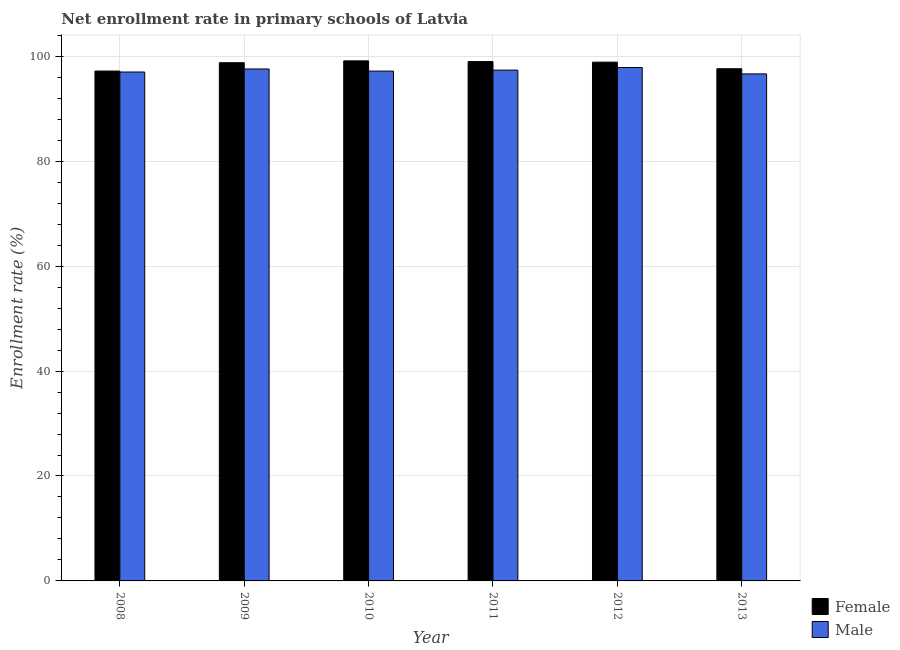How many groups of bars are there?
Ensure brevity in your answer.  6. Are the number of bars on each tick of the X-axis equal?
Ensure brevity in your answer.  Yes. How many bars are there on the 1st tick from the left?
Offer a terse response. 2. How many bars are there on the 6th tick from the right?
Offer a terse response. 2. What is the enrollment rate of male students in 2013?
Offer a very short reply. 96.65. Across all years, what is the maximum enrollment rate of male students?
Provide a succinct answer. 97.86. Across all years, what is the minimum enrollment rate of male students?
Give a very brief answer. 96.65. In which year was the enrollment rate of female students maximum?
Your response must be concise. 2010. What is the total enrollment rate of female students in the graph?
Ensure brevity in your answer.  590.6. What is the difference between the enrollment rate of male students in 2008 and that in 2009?
Your answer should be very brief. -0.58. What is the difference between the enrollment rate of male students in 2010 and the enrollment rate of female students in 2013?
Give a very brief answer. 0.53. What is the average enrollment rate of female students per year?
Keep it short and to the point. 98.43. In the year 2008, what is the difference between the enrollment rate of male students and enrollment rate of female students?
Make the answer very short. 0. What is the ratio of the enrollment rate of female students in 2008 to that in 2010?
Your response must be concise. 0.98. Is the enrollment rate of male students in 2008 less than that in 2011?
Your answer should be very brief. Yes. Is the difference between the enrollment rate of female students in 2009 and 2011 greater than the difference between the enrollment rate of male students in 2009 and 2011?
Offer a very short reply. No. What is the difference between the highest and the second highest enrollment rate of male students?
Give a very brief answer. 0.28. What is the difference between the highest and the lowest enrollment rate of male students?
Your response must be concise. 1.22. Is the sum of the enrollment rate of female students in 2009 and 2011 greater than the maximum enrollment rate of male students across all years?
Your answer should be compact. Yes. How many bars are there?
Offer a terse response. 12. Are all the bars in the graph horizontal?
Give a very brief answer. No. Does the graph contain grids?
Make the answer very short. Yes. How many legend labels are there?
Ensure brevity in your answer.  2. What is the title of the graph?
Offer a very short reply. Net enrollment rate in primary schools of Latvia. Does "Current education expenditure" appear as one of the legend labels in the graph?
Make the answer very short. No. What is the label or title of the X-axis?
Keep it short and to the point. Year. What is the label or title of the Y-axis?
Your answer should be compact. Enrollment rate (%). What is the Enrollment rate (%) of Female in 2008?
Provide a short and direct response. 97.19. What is the Enrollment rate (%) in Male in 2008?
Keep it short and to the point. 97. What is the Enrollment rate (%) in Female in 2009?
Your response must be concise. 98.78. What is the Enrollment rate (%) of Male in 2009?
Provide a short and direct response. 97.58. What is the Enrollment rate (%) of Female in 2010?
Make the answer very short. 99.13. What is the Enrollment rate (%) in Male in 2010?
Ensure brevity in your answer.  97.18. What is the Enrollment rate (%) of Female in 2011?
Make the answer very short. 99. What is the Enrollment rate (%) of Male in 2011?
Provide a short and direct response. 97.37. What is the Enrollment rate (%) of Female in 2012?
Your answer should be very brief. 98.88. What is the Enrollment rate (%) of Male in 2012?
Keep it short and to the point. 97.86. What is the Enrollment rate (%) in Female in 2013?
Make the answer very short. 97.63. What is the Enrollment rate (%) in Male in 2013?
Offer a very short reply. 96.65. Across all years, what is the maximum Enrollment rate (%) of Female?
Offer a very short reply. 99.13. Across all years, what is the maximum Enrollment rate (%) in Male?
Keep it short and to the point. 97.86. Across all years, what is the minimum Enrollment rate (%) of Female?
Ensure brevity in your answer.  97.19. Across all years, what is the minimum Enrollment rate (%) in Male?
Your answer should be compact. 96.65. What is the total Enrollment rate (%) in Female in the graph?
Offer a terse response. 590.6. What is the total Enrollment rate (%) in Male in the graph?
Provide a short and direct response. 583.65. What is the difference between the Enrollment rate (%) in Female in 2008 and that in 2009?
Ensure brevity in your answer.  -1.59. What is the difference between the Enrollment rate (%) in Male in 2008 and that in 2009?
Your response must be concise. -0.58. What is the difference between the Enrollment rate (%) of Female in 2008 and that in 2010?
Your response must be concise. -1.94. What is the difference between the Enrollment rate (%) of Male in 2008 and that in 2010?
Your answer should be very brief. -0.18. What is the difference between the Enrollment rate (%) in Female in 2008 and that in 2011?
Offer a terse response. -1.81. What is the difference between the Enrollment rate (%) in Male in 2008 and that in 2011?
Your response must be concise. -0.36. What is the difference between the Enrollment rate (%) in Female in 2008 and that in 2012?
Offer a terse response. -1.7. What is the difference between the Enrollment rate (%) in Male in 2008 and that in 2012?
Your answer should be very brief. -0.86. What is the difference between the Enrollment rate (%) in Female in 2008 and that in 2013?
Make the answer very short. -0.44. What is the difference between the Enrollment rate (%) in Male in 2008 and that in 2013?
Keep it short and to the point. 0.36. What is the difference between the Enrollment rate (%) in Female in 2009 and that in 2010?
Ensure brevity in your answer.  -0.35. What is the difference between the Enrollment rate (%) of Male in 2009 and that in 2010?
Give a very brief answer. 0.4. What is the difference between the Enrollment rate (%) of Female in 2009 and that in 2011?
Make the answer very short. -0.22. What is the difference between the Enrollment rate (%) in Male in 2009 and that in 2011?
Provide a succinct answer. 0.22. What is the difference between the Enrollment rate (%) of Female in 2009 and that in 2012?
Keep it short and to the point. -0.1. What is the difference between the Enrollment rate (%) in Male in 2009 and that in 2012?
Offer a terse response. -0.28. What is the difference between the Enrollment rate (%) of Female in 2009 and that in 2013?
Offer a very short reply. 1.15. What is the difference between the Enrollment rate (%) in Male in 2009 and that in 2013?
Your answer should be compact. 0.94. What is the difference between the Enrollment rate (%) in Female in 2010 and that in 2011?
Provide a succinct answer. 0.13. What is the difference between the Enrollment rate (%) of Male in 2010 and that in 2011?
Your answer should be very brief. -0.19. What is the difference between the Enrollment rate (%) in Female in 2010 and that in 2012?
Ensure brevity in your answer.  0.24. What is the difference between the Enrollment rate (%) in Male in 2010 and that in 2012?
Offer a very short reply. -0.68. What is the difference between the Enrollment rate (%) in Female in 2010 and that in 2013?
Ensure brevity in your answer.  1.5. What is the difference between the Enrollment rate (%) of Male in 2010 and that in 2013?
Give a very brief answer. 0.53. What is the difference between the Enrollment rate (%) of Female in 2011 and that in 2012?
Provide a succinct answer. 0.12. What is the difference between the Enrollment rate (%) of Male in 2011 and that in 2012?
Your answer should be very brief. -0.5. What is the difference between the Enrollment rate (%) of Female in 2011 and that in 2013?
Your response must be concise. 1.37. What is the difference between the Enrollment rate (%) of Male in 2011 and that in 2013?
Keep it short and to the point. 0.72. What is the difference between the Enrollment rate (%) of Female in 2012 and that in 2013?
Ensure brevity in your answer.  1.26. What is the difference between the Enrollment rate (%) of Male in 2012 and that in 2013?
Your answer should be compact. 1.22. What is the difference between the Enrollment rate (%) in Female in 2008 and the Enrollment rate (%) in Male in 2009?
Keep it short and to the point. -0.4. What is the difference between the Enrollment rate (%) in Female in 2008 and the Enrollment rate (%) in Male in 2010?
Provide a short and direct response. 0.01. What is the difference between the Enrollment rate (%) of Female in 2008 and the Enrollment rate (%) of Male in 2011?
Provide a short and direct response. -0.18. What is the difference between the Enrollment rate (%) in Female in 2008 and the Enrollment rate (%) in Male in 2012?
Ensure brevity in your answer.  -0.68. What is the difference between the Enrollment rate (%) in Female in 2008 and the Enrollment rate (%) in Male in 2013?
Keep it short and to the point. 0.54. What is the difference between the Enrollment rate (%) in Female in 2009 and the Enrollment rate (%) in Male in 2010?
Give a very brief answer. 1.6. What is the difference between the Enrollment rate (%) in Female in 2009 and the Enrollment rate (%) in Male in 2011?
Provide a succinct answer. 1.41. What is the difference between the Enrollment rate (%) of Female in 2009 and the Enrollment rate (%) of Male in 2012?
Provide a short and direct response. 0.91. What is the difference between the Enrollment rate (%) of Female in 2009 and the Enrollment rate (%) of Male in 2013?
Offer a terse response. 2.13. What is the difference between the Enrollment rate (%) of Female in 2010 and the Enrollment rate (%) of Male in 2011?
Give a very brief answer. 1.76. What is the difference between the Enrollment rate (%) of Female in 2010 and the Enrollment rate (%) of Male in 2012?
Offer a very short reply. 1.26. What is the difference between the Enrollment rate (%) in Female in 2010 and the Enrollment rate (%) in Male in 2013?
Your answer should be very brief. 2.48. What is the difference between the Enrollment rate (%) of Female in 2011 and the Enrollment rate (%) of Male in 2012?
Your response must be concise. 1.13. What is the difference between the Enrollment rate (%) of Female in 2011 and the Enrollment rate (%) of Male in 2013?
Provide a short and direct response. 2.35. What is the difference between the Enrollment rate (%) of Female in 2012 and the Enrollment rate (%) of Male in 2013?
Give a very brief answer. 2.23. What is the average Enrollment rate (%) of Female per year?
Keep it short and to the point. 98.43. What is the average Enrollment rate (%) in Male per year?
Offer a very short reply. 97.27. In the year 2008, what is the difference between the Enrollment rate (%) of Female and Enrollment rate (%) of Male?
Your answer should be compact. 0.18. In the year 2009, what is the difference between the Enrollment rate (%) of Female and Enrollment rate (%) of Male?
Offer a very short reply. 1.19. In the year 2010, what is the difference between the Enrollment rate (%) in Female and Enrollment rate (%) in Male?
Offer a terse response. 1.95. In the year 2011, what is the difference between the Enrollment rate (%) of Female and Enrollment rate (%) of Male?
Offer a very short reply. 1.63. In the year 2012, what is the difference between the Enrollment rate (%) in Female and Enrollment rate (%) in Male?
Keep it short and to the point. 1.02. In the year 2013, what is the difference between the Enrollment rate (%) in Female and Enrollment rate (%) in Male?
Make the answer very short. 0.98. What is the ratio of the Enrollment rate (%) of Female in 2008 to that in 2009?
Your answer should be very brief. 0.98. What is the ratio of the Enrollment rate (%) in Female in 2008 to that in 2010?
Make the answer very short. 0.98. What is the ratio of the Enrollment rate (%) of Female in 2008 to that in 2011?
Give a very brief answer. 0.98. What is the ratio of the Enrollment rate (%) of Male in 2008 to that in 2011?
Ensure brevity in your answer.  1. What is the ratio of the Enrollment rate (%) in Female in 2008 to that in 2012?
Make the answer very short. 0.98. What is the ratio of the Enrollment rate (%) in Female in 2009 to that in 2011?
Make the answer very short. 1. What is the ratio of the Enrollment rate (%) in Male in 2009 to that in 2011?
Provide a short and direct response. 1. What is the ratio of the Enrollment rate (%) of Female in 2009 to that in 2012?
Offer a very short reply. 1. What is the ratio of the Enrollment rate (%) of Female in 2009 to that in 2013?
Your answer should be very brief. 1.01. What is the ratio of the Enrollment rate (%) in Male in 2009 to that in 2013?
Give a very brief answer. 1.01. What is the ratio of the Enrollment rate (%) in Male in 2010 to that in 2011?
Ensure brevity in your answer.  1. What is the ratio of the Enrollment rate (%) of Female in 2010 to that in 2012?
Give a very brief answer. 1. What is the ratio of the Enrollment rate (%) of Male in 2010 to that in 2012?
Keep it short and to the point. 0.99. What is the ratio of the Enrollment rate (%) of Female in 2010 to that in 2013?
Your answer should be very brief. 1.02. What is the ratio of the Enrollment rate (%) in Male in 2010 to that in 2013?
Your answer should be compact. 1.01. What is the ratio of the Enrollment rate (%) in Male in 2011 to that in 2013?
Ensure brevity in your answer.  1.01. What is the ratio of the Enrollment rate (%) of Female in 2012 to that in 2013?
Make the answer very short. 1.01. What is the ratio of the Enrollment rate (%) in Male in 2012 to that in 2013?
Your answer should be compact. 1.01. What is the difference between the highest and the second highest Enrollment rate (%) in Female?
Give a very brief answer. 0.13. What is the difference between the highest and the second highest Enrollment rate (%) of Male?
Offer a terse response. 0.28. What is the difference between the highest and the lowest Enrollment rate (%) of Female?
Offer a terse response. 1.94. What is the difference between the highest and the lowest Enrollment rate (%) in Male?
Your response must be concise. 1.22. 